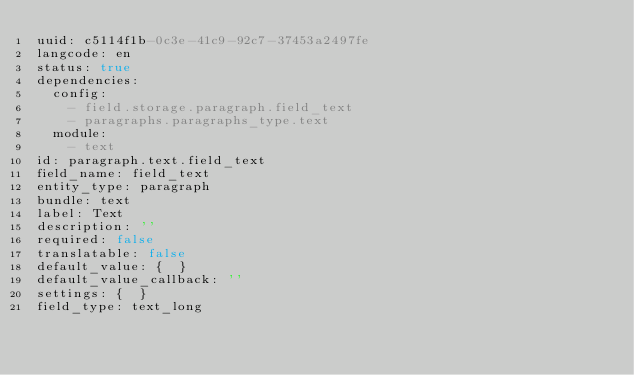<code> <loc_0><loc_0><loc_500><loc_500><_YAML_>uuid: c5114f1b-0c3e-41c9-92c7-37453a2497fe
langcode: en
status: true
dependencies:
  config:
    - field.storage.paragraph.field_text
    - paragraphs.paragraphs_type.text
  module:
    - text
id: paragraph.text.field_text
field_name: field_text
entity_type: paragraph
bundle: text
label: Text
description: ''
required: false
translatable: false
default_value: {  }
default_value_callback: ''
settings: {  }
field_type: text_long
</code> 